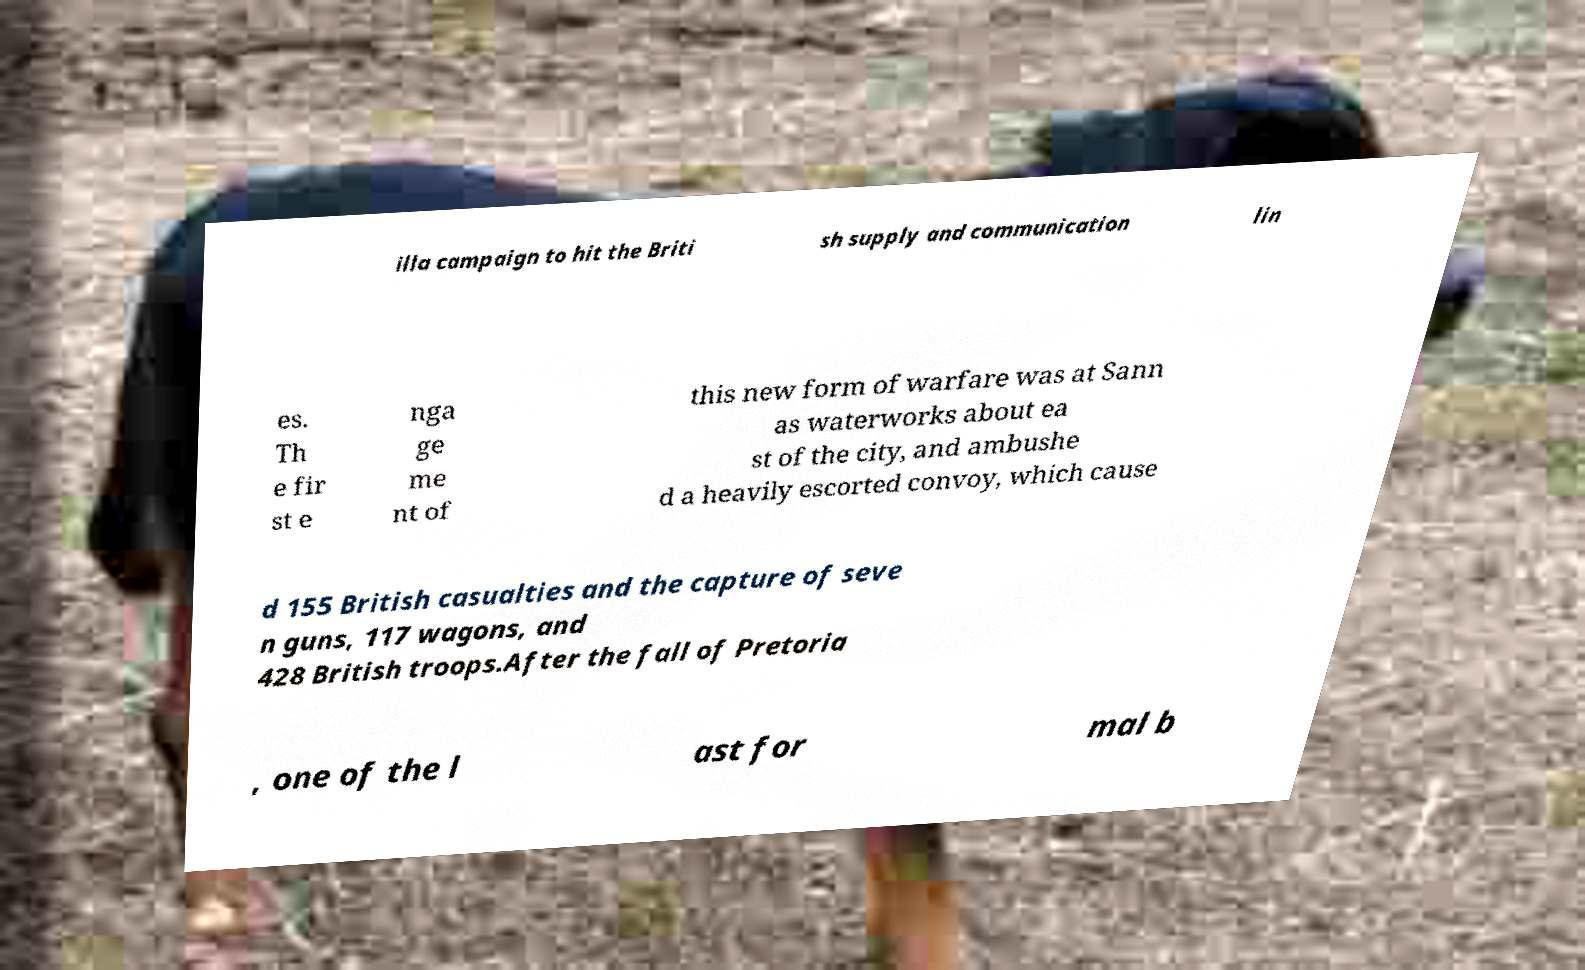For documentation purposes, I need the text within this image transcribed. Could you provide that? illa campaign to hit the Briti sh supply and communication lin es. Th e fir st e nga ge me nt of this new form of warfare was at Sann as waterworks about ea st of the city, and ambushe d a heavily escorted convoy, which cause d 155 British casualties and the capture of seve n guns, 117 wagons, and 428 British troops.After the fall of Pretoria , one of the l ast for mal b 